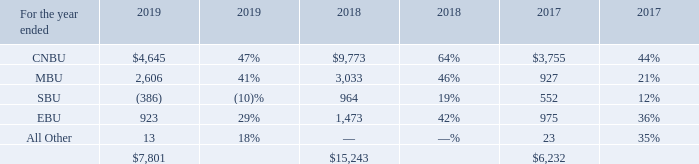Operating Income (Loss) by Business Unit
Percentages reflect operating income (loss) as a percentage of revenue for each business unit.
CNBU operating income for 2019 decreased from 2018 primarily due to declines in pricing and higher R&D costs, partially offset by cost reductions. MBU operating income for 2019 decreased from 2018 primarily due to declines in pricing partially offset by increases in sales of high-value managed NAND products and manufacturing cost reductions. SBU operating margin for 2019 declined from 2018 primarily due to declines in pricing, which were partially offset by manufacturing cost reductions and increases in sales volumes. SBU operating results for 2019 and 2018 were adversely impacted by the underutilization charges at IMFT. EBU operating income for 2019 decreased from 2018 as a result of declines in pricing and higher R&D costs partially offset by manufacturing cost reductions and increases in sales volumes.
CNBU operating income for 2018 improved from 2017 primarily due to improved pricing and higher sales volumes resulting from strong demand for our products combined with manufacturing cost reductions. MBU operating income for 2018 improved from 2017 primarily due to increases in pricing and sales volumes for LPDRAM products, higher sales of high-value managed NAND products, and manufacturing cost reductions. SBU operating income for 2018 improved from 2017 primarily due to manufacturing cost reductions enabled by our execution in transitioning to 64-layer TLC 3D NAND products and improvements in product mix. SBU operating income for 2018 was adversely impacted by higher costs associated with IMFT's production of 3D XPoint memory products at less than full capacity. EBU operating income for 2018 increased as compared to 2017 as a result of increases in average selling prices, manufacturing cost reductions, and increases in sales volumes, partially offset by higher R&D costs.
What was the primary cause of CNBU operating income for 2019 decreased from 2018? Declines in pricing and higher r&d costs, partially offset by cost reductions. Why did MBU operating income for 2018 improved from 2017? Increases in pricing and sales volumes for lpdram products, higher sales of high-value managed nand products, and manufacturing cost reductions. Why did EBU operating income for 2018 increased as compared to 2017? Increases in average selling prices, manufacturing cost reductions, and increases in sales volumes, partially offset by higher r&d costs. What is the difference between EBU operating income in 2017 and 2018? 1,473 - 975 
Answer: 498. What is the ratio of CNBU and MBU total operating income in 2019 to those in 2018? (4,645+2,606)/(9,773+3,033)
Answer: 0.57. How much difference in the total operating income in 2018 compared to in 2017? 15,243 - 6,232 
Answer: 9011. 